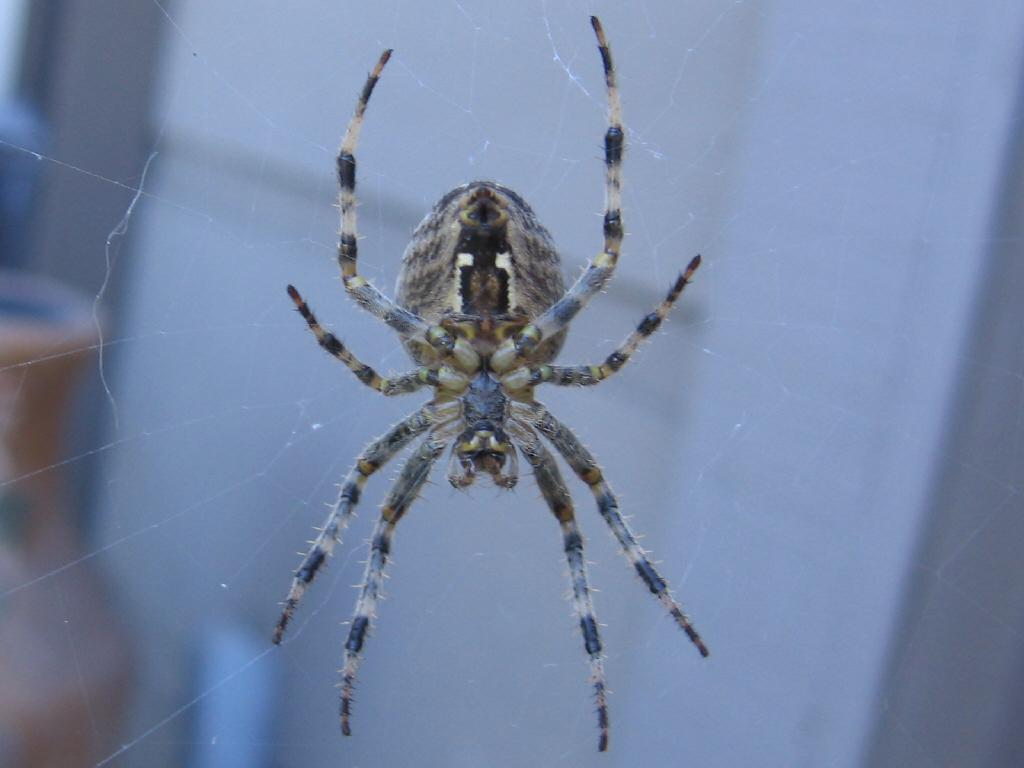What is the main subject of the image? The main subject of the image is a spider. Where is the spider located? The spider is in a spider web. What can be seen in the background of the image? There is a wall visible in the image. Are there any other objects present in the image? Yes, there is a pot on the side in the image. What type of bottle can be seen in the image? There is no bottle present in the image. Is there a button on the spider in the image? Spiders do not have buttons, and there is no button present in the image. 